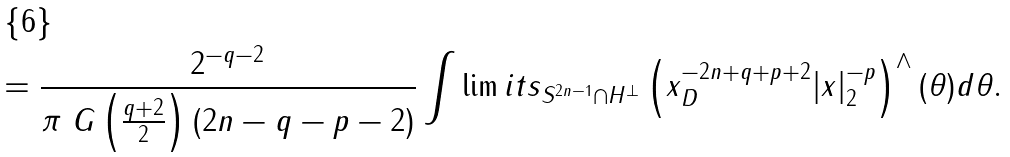<formula> <loc_0><loc_0><loc_500><loc_500>= \frac { 2 ^ { - q - 2 } } { \pi \ G \left ( \frac { q + 2 } { 2 } \right ) ( 2 n - q - p - 2 ) } \int \lim i t s _ { S ^ { 2 n - 1 } \cap H ^ { \perp } } \left ( \| x \| _ { D } ^ { - 2 n + q + p + 2 } | x | _ { 2 } ^ { - p } \right ) ^ { \wedge } ( \theta ) d \theta .</formula> 